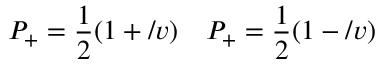Convert formula to latex. <formula><loc_0><loc_0><loc_500><loc_500>P _ { + } = \frac { 1 } { 2 } ( 1 + \slash { v } ) \quad P _ { + } = \frac { 1 } { 2 } ( 1 - \slash { v } )</formula> 